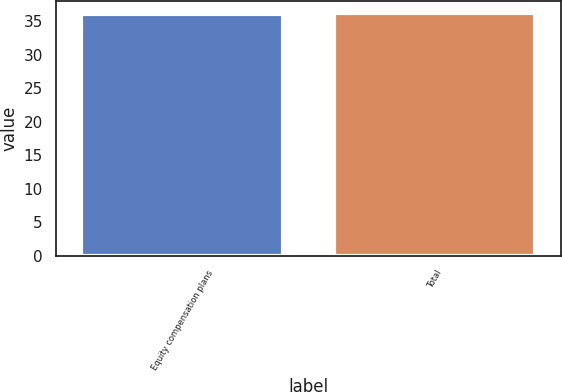<chart> <loc_0><loc_0><loc_500><loc_500><bar_chart><fcel>Equity compensation plans<fcel>Total<nl><fcel>36.12<fcel>36.22<nl></chart> 